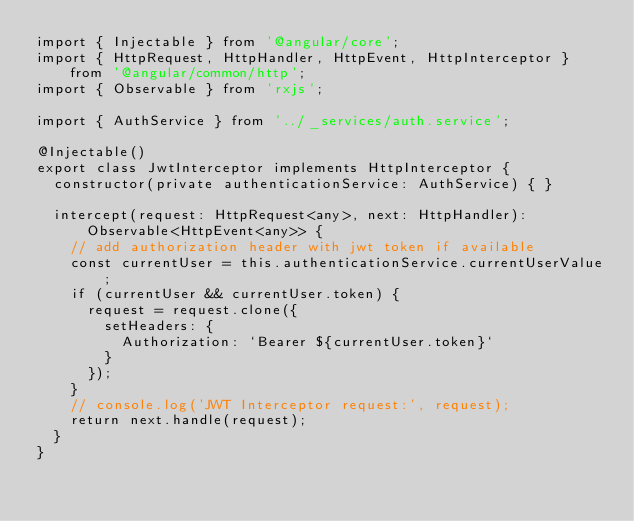<code> <loc_0><loc_0><loc_500><loc_500><_TypeScript_>import { Injectable } from '@angular/core';
import { HttpRequest, HttpHandler, HttpEvent, HttpInterceptor } from '@angular/common/http';
import { Observable } from 'rxjs';

import { AuthService } from '../_services/auth.service';

@Injectable()
export class JwtInterceptor implements HttpInterceptor {
  constructor(private authenticationService: AuthService) { }

  intercept(request: HttpRequest<any>, next: HttpHandler): Observable<HttpEvent<any>> {
    // add authorization header with jwt token if available
    const currentUser = this.authenticationService.currentUserValue;
    if (currentUser && currentUser.token) {
      request = request.clone({
        setHeaders: {
          Authorization: `Bearer ${currentUser.token}`
        }
      });
    }
    // console.log('JWT Interceptor request:', request);
    return next.handle(request);
  }
}
</code> 